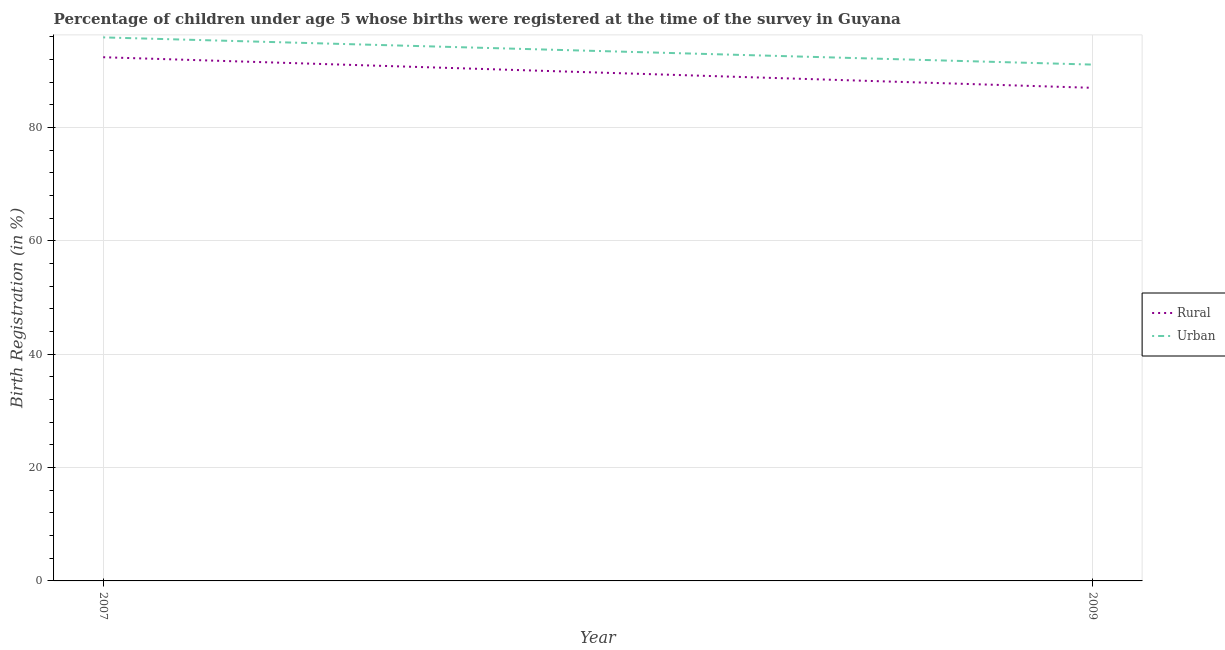How many different coloured lines are there?
Offer a terse response. 2. What is the urban birth registration in 2009?
Your answer should be compact. 91.1. Across all years, what is the maximum urban birth registration?
Your answer should be very brief. 95.9. Across all years, what is the minimum rural birth registration?
Ensure brevity in your answer.  87. What is the total urban birth registration in the graph?
Offer a terse response. 187. What is the difference between the rural birth registration in 2007 and that in 2009?
Give a very brief answer. 5.4. What is the difference between the rural birth registration in 2007 and the urban birth registration in 2009?
Keep it short and to the point. 1.3. What is the average rural birth registration per year?
Your answer should be compact. 89.7. In the year 2009, what is the difference between the urban birth registration and rural birth registration?
Your answer should be very brief. 4.1. In how many years, is the rural birth registration greater than 40 %?
Offer a very short reply. 2. What is the ratio of the rural birth registration in 2007 to that in 2009?
Ensure brevity in your answer.  1.06. Is the urban birth registration in 2007 less than that in 2009?
Your answer should be very brief. No. Is the urban birth registration strictly less than the rural birth registration over the years?
Provide a short and direct response. No. How many lines are there?
Make the answer very short. 2. What is the title of the graph?
Keep it short and to the point. Percentage of children under age 5 whose births were registered at the time of the survey in Guyana. What is the label or title of the Y-axis?
Offer a very short reply. Birth Registration (in %). What is the Birth Registration (in %) of Rural in 2007?
Provide a short and direct response. 92.4. What is the Birth Registration (in %) in Urban in 2007?
Make the answer very short. 95.9. What is the Birth Registration (in %) in Rural in 2009?
Provide a succinct answer. 87. What is the Birth Registration (in %) of Urban in 2009?
Offer a very short reply. 91.1. Across all years, what is the maximum Birth Registration (in %) of Rural?
Offer a very short reply. 92.4. Across all years, what is the maximum Birth Registration (in %) in Urban?
Make the answer very short. 95.9. Across all years, what is the minimum Birth Registration (in %) in Urban?
Make the answer very short. 91.1. What is the total Birth Registration (in %) of Rural in the graph?
Offer a terse response. 179.4. What is the total Birth Registration (in %) in Urban in the graph?
Give a very brief answer. 187. What is the difference between the Birth Registration (in %) of Rural in 2007 and that in 2009?
Make the answer very short. 5.4. What is the average Birth Registration (in %) of Rural per year?
Make the answer very short. 89.7. What is the average Birth Registration (in %) of Urban per year?
Provide a succinct answer. 93.5. In the year 2007, what is the difference between the Birth Registration (in %) of Rural and Birth Registration (in %) of Urban?
Ensure brevity in your answer.  -3.5. What is the ratio of the Birth Registration (in %) in Rural in 2007 to that in 2009?
Your answer should be very brief. 1.06. What is the ratio of the Birth Registration (in %) in Urban in 2007 to that in 2009?
Provide a short and direct response. 1.05. What is the difference between the highest and the lowest Birth Registration (in %) of Rural?
Ensure brevity in your answer.  5.4. What is the difference between the highest and the lowest Birth Registration (in %) of Urban?
Your answer should be very brief. 4.8. 